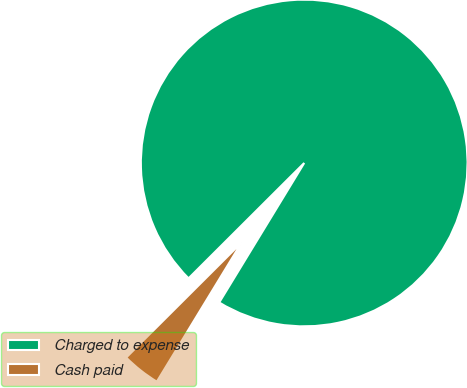Convert chart to OTSL. <chart><loc_0><loc_0><loc_500><loc_500><pie_chart><fcel>Charged to expense<fcel>Cash paid<nl><fcel>96.19%<fcel>3.81%<nl></chart> 